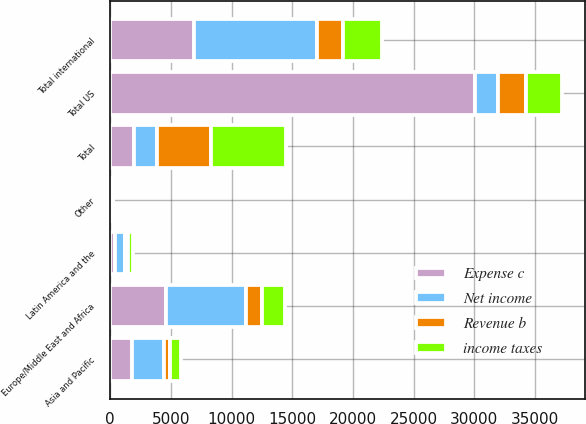Convert chart. <chart><loc_0><loc_0><loc_500><loc_500><stacked_bar_chart><ecel><fcel>Europe/Middle East and Africa<fcel>Asia and Pacific<fcel>Latin America and the<fcel>Other<fcel>Total international<fcel>Total US<fcel>Total<nl><fcel>Net income<fcel>6566<fcel>2631<fcel>816<fcel>112<fcel>10125<fcel>1931<fcel>1931<nl><fcel>Expense c<fcel>4635<fcel>1766<fcel>411<fcel>77<fcel>6889<fcel>30014<fcel>1931<nl><fcel>income taxes<fcel>1931<fcel>865<fcel>405<fcel>35<fcel>3236<fcel>2958<fcel>6194<nl><fcel>Revenue b<fcel>1305<fcel>547<fcel>255<fcel>25<fcel>2132<fcel>2334<fcel>4466<nl></chart> 